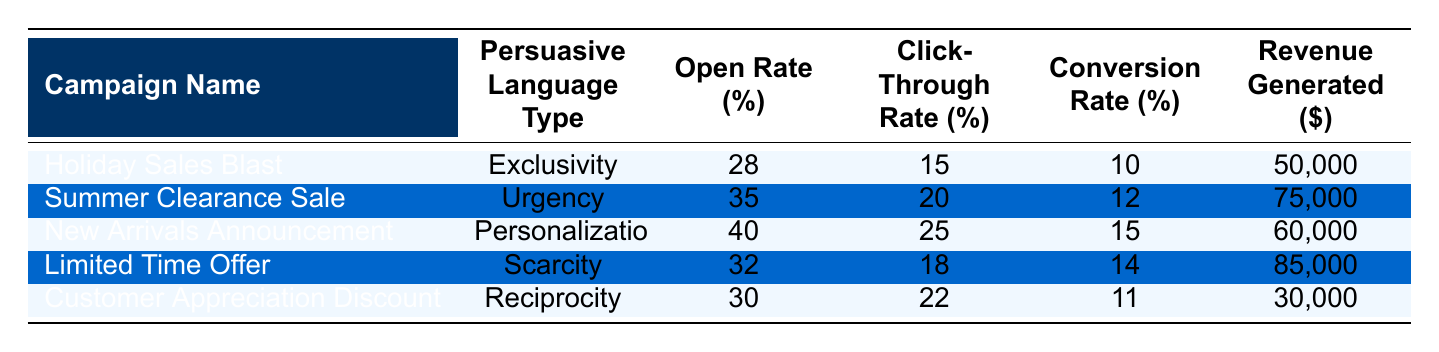What is the open rate percentage for the "Limited Time Offer" campaign? The "Limited Time Offer" campaign is listed in the table, and the corresponding open rate percentage is directly readable from the relevant row.
Answer: 32 Which campaign generated the highest revenue? The "Limited Time Offer" campaign shows the highest revenue generated at $85,000 when compared with the revenue figures from all other campaigns listed.
Answer: Limited Time Offer Is the average conversion rate across all campaigns greater than 12%? To find the average, add the conversion rates: (10 + 12 + 15 + 14 + 11) = 62. Then divide by the number of campaigns (5): 62/5 = 12.4%. Since 12.4% is greater than 12%, the answer is yes.
Answer: Yes What is the total revenue generated from campaigns that used "Urgency" and "Scarcity"? The revenue from "Summer Clearance Sale" (Urgency) is $75,000 and from "Limited Time Offer" (Scarcity) is $85,000. Adding these gives 75,000 + 85,000 = 160,000.
Answer: 160,000 Does the "New Arrivals Announcement" campaign have a higher click-through rate than the "Customer Appreciation Discount" campaign? The click-through rate for "New Arrivals Announcement" is 25%, while for "Customer Appreciation Discount" it is 22%. Since 25% is greater than 22%, the answer is yes.
Answer: Yes What is the difference in open rates between the "Summer Clearance Sale" and "Customer Appreciation Discount" campaigns? The open rate for "Summer Clearance Sale" is 35% and for "Customer Appreciation Discount" it is 30%. The difference is 35 - 30 = 5%.
Answer: 5 Which persuasive language type had the highest click-through rate percentage? The "New Arrivals Announcement" with a click-through rate of 25% is identifiable in the table. It is higher than the other types listed, making it the highest.
Answer: Personalization What is the total conversion rate from campaigns using "Reciprocity" and "Exclusivity"? The conversion rate for "Customer Appreciation Discount" (Reciprocity) is 11% and for "Holiday Sales Blast" (Exclusivity) it is 10%. Adding these gives 11 + 10 = 21%.
Answer: 21 